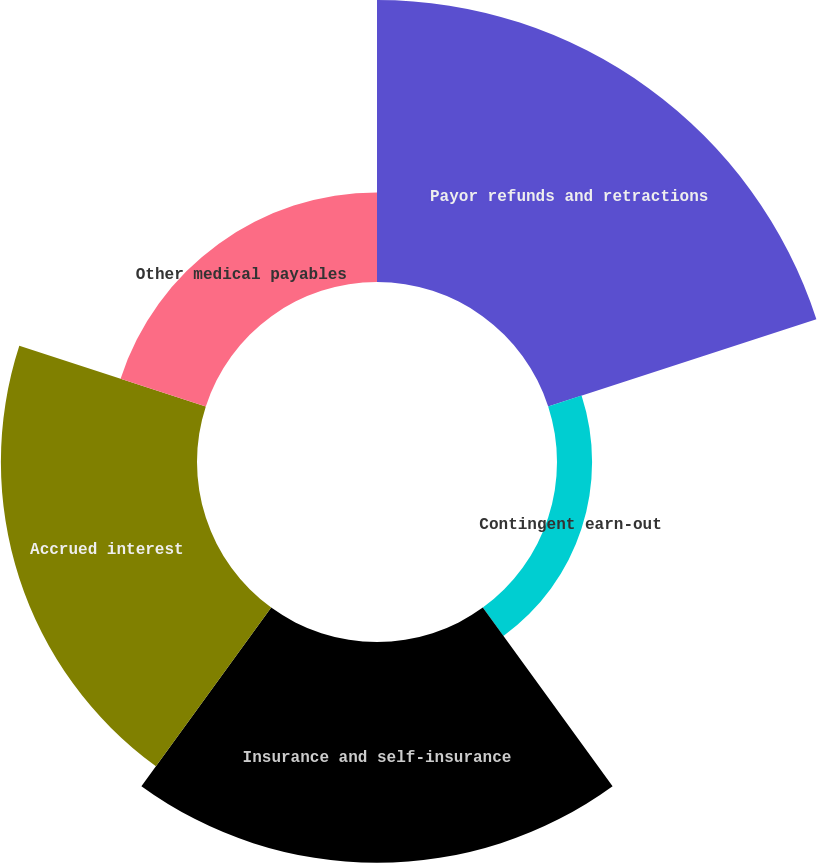Convert chart. <chart><loc_0><loc_0><loc_500><loc_500><pie_chart><fcel>Payor refunds and retractions<fcel>Contingent earn-out<fcel>Insurance and self-insurance<fcel>Accrued interest<fcel>Other medical payables<nl><fcel>34.24%<fcel>4.26%<fcel>26.81%<fcel>23.81%<fcel>10.88%<nl></chart> 